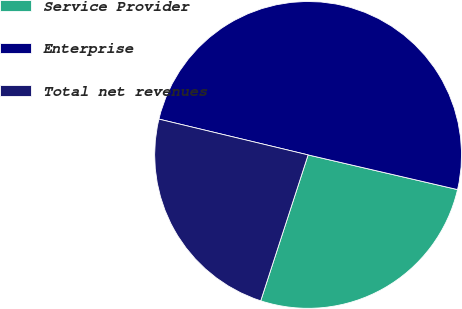Convert chart to OTSL. <chart><loc_0><loc_0><loc_500><loc_500><pie_chart><fcel>Service Provider<fcel>Enterprise<fcel>Total net revenues<nl><fcel>26.37%<fcel>49.88%<fcel>23.75%<nl></chart> 